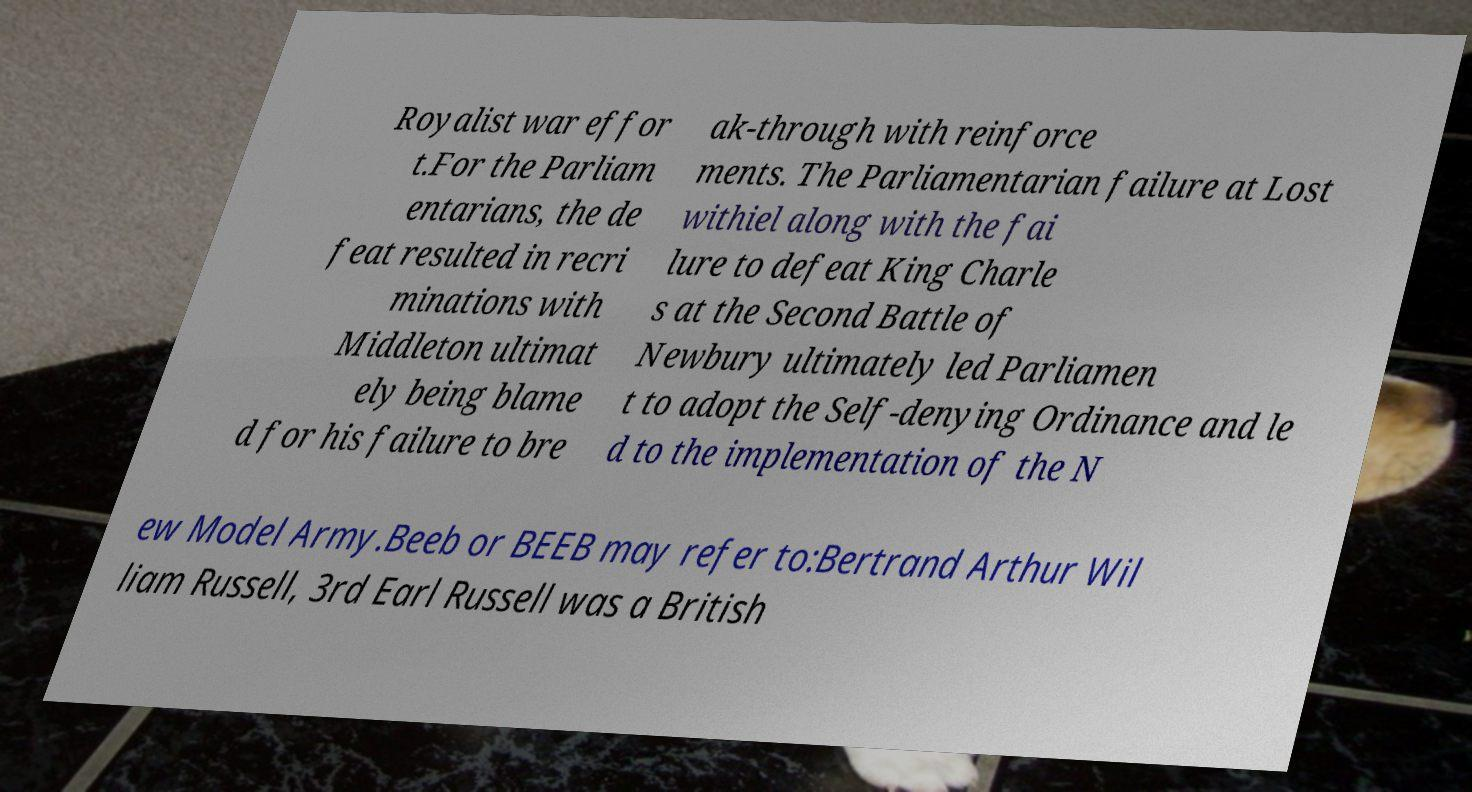Can you read and provide the text displayed in the image? This photo seems to have some interesting text. Can you extract and type it out for me? The text in the image reads: 'Royalist war effort. For the Parliamentarians, the defeat resulted in recriminations with Middleton ultimately being blamed for his failure to breakthrough with reinforcements. The Parliamentarian failure at Lostwithiel along with the failure to defeat King Charles at the Second Battle of Newbury ultimately led Parliament to adopt the Self-denying Ordinance and led to the implementation of the New Model Army. Beeb or BEEB may refer to: Bertrand Arthur William Russell, 3rd Earl Russell was a British.' 